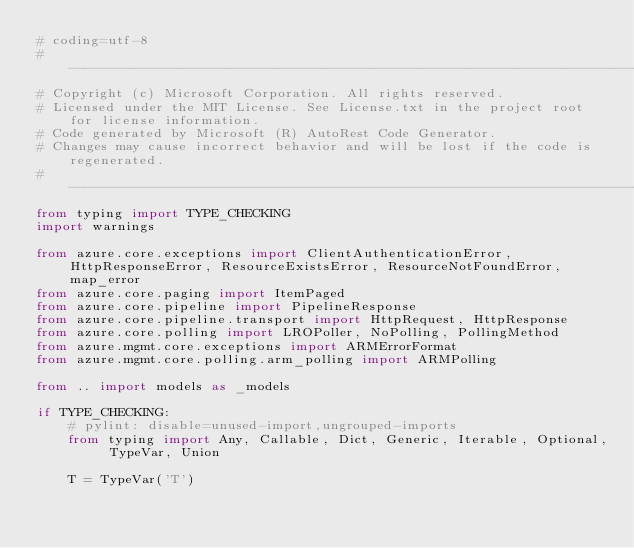<code> <loc_0><loc_0><loc_500><loc_500><_Python_># coding=utf-8
# --------------------------------------------------------------------------
# Copyright (c) Microsoft Corporation. All rights reserved.
# Licensed under the MIT License. See License.txt in the project root for license information.
# Code generated by Microsoft (R) AutoRest Code Generator.
# Changes may cause incorrect behavior and will be lost if the code is regenerated.
# --------------------------------------------------------------------------
from typing import TYPE_CHECKING
import warnings

from azure.core.exceptions import ClientAuthenticationError, HttpResponseError, ResourceExistsError, ResourceNotFoundError, map_error
from azure.core.paging import ItemPaged
from azure.core.pipeline import PipelineResponse
from azure.core.pipeline.transport import HttpRequest, HttpResponse
from azure.core.polling import LROPoller, NoPolling, PollingMethod
from azure.mgmt.core.exceptions import ARMErrorFormat
from azure.mgmt.core.polling.arm_polling import ARMPolling

from .. import models as _models

if TYPE_CHECKING:
    # pylint: disable=unused-import,ungrouped-imports
    from typing import Any, Callable, Dict, Generic, Iterable, Optional, TypeVar, Union

    T = TypeVar('T')</code> 